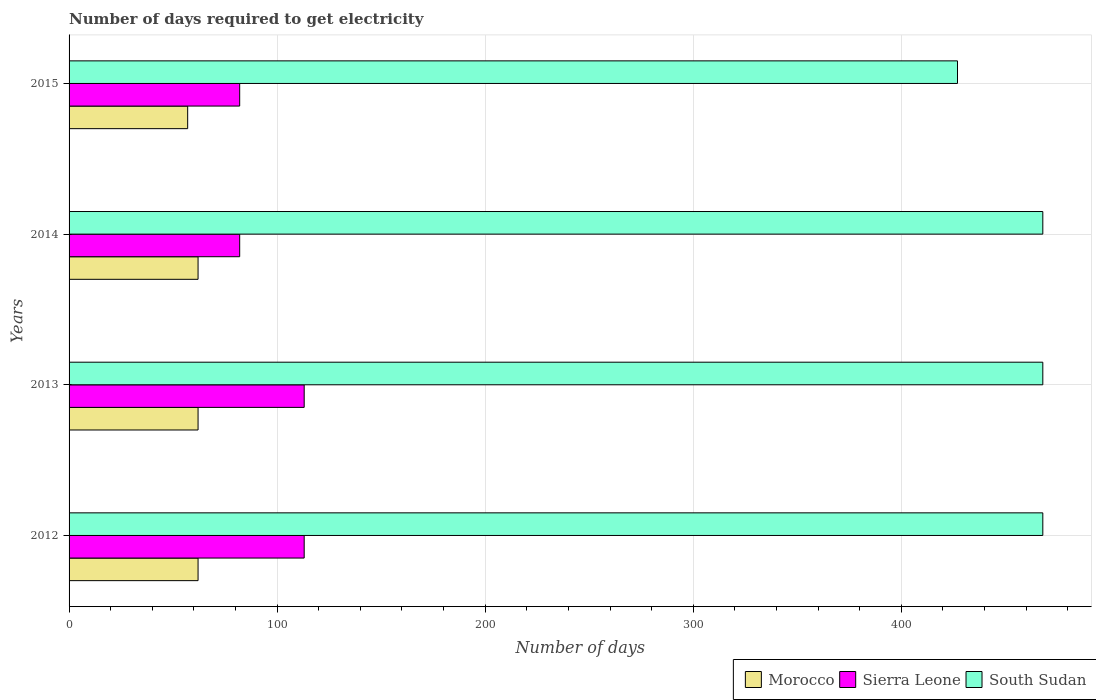How many different coloured bars are there?
Your answer should be compact. 3. Are the number of bars per tick equal to the number of legend labels?
Make the answer very short. Yes. How many bars are there on the 2nd tick from the top?
Give a very brief answer. 3. How many bars are there on the 4th tick from the bottom?
Provide a succinct answer. 3. What is the label of the 2nd group of bars from the top?
Keep it short and to the point. 2014. What is the number of days required to get electricity in in Sierra Leone in 2012?
Provide a short and direct response. 113. Across all years, what is the maximum number of days required to get electricity in in Morocco?
Your answer should be very brief. 62. Across all years, what is the minimum number of days required to get electricity in in South Sudan?
Offer a terse response. 427. What is the total number of days required to get electricity in in South Sudan in the graph?
Give a very brief answer. 1831. What is the difference between the number of days required to get electricity in in Sierra Leone in 2012 and that in 2015?
Give a very brief answer. 31. What is the difference between the number of days required to get electricity in in Morocco in 2013 and the number of days required to get electricity in in Sierra Leone in 2012?
Ensure brevity in your answer.  -51. What is the average number of days required to get electricity in in Morocco per year?
Give a very brief answer. 60.75. In the year 2012, what is the difference between the number of days required to get electricity in in South Sudan and number of days required to get electricity in in Sierra Leone?
Offer a terse response. 355. Is the difference between the number of days required to get electricity in in South Sudan in 2013 and 2014 greater than the difference between the number of days required to get electricity in in Sierra Leone in 2013 and 2014?
Offer a terse response. No. What is the difference between the highest and the second highest number of days required to get electricity in in South Sudan?
Your answer should be compact. 0. What is the difference between the highest and the lowest number of days required to get electricity in in South Sudan?
Ensure brevity in your answer.  41. Is the sum of the number of days required to get electricity in in South Sudan in 2012 and 2013 greater than the maximum number of days required to get electricity in in Morocco across all years?
Provide a short and direct response. Yes. What does the 1st bar from the top in 2014 represents?
Give a very brief answer. South Sudan. What does the 2nd bar from the bottom in 2013 represents?
Your response must be concise. Sierra Leone. Is it the case that in every year, the sum of the number of days required to get electricity in in Morocco and number of days required to get electricity in in South Sudan is greater than the number of days required to get electricity in in Sierra Leone?
Offer a very short reply. Yes. How many years are there in the graph?
Provide a short and direct response. 4. What is the difference between two consecutive major ticks on the X-axis?
Offer a very short reply. 100. Are the values on the major ticks of X-axis written in scientific E-notation?
Offer a terse response. No. Where does the legend appear in the graph?
Your response must be concise. Bottom right. How many legend labels are there?
Offer a terse response. 3. What is the title of the graph?
Provide a short and direct response. Number of days required to get electricity. Does "St. Martin (French part)" appear as one of the legend labels in the graph?
Your answer should be very brief. No. What is the label or title of the X-axis?
Make the answer very short. Number of days. What is the label or title of the Y-axis?
Keep it short and to the point. Years. What is the Number of days in Morocco in 2012?
Your answer should be compact. 62. What is the Number of days in Sierra Leone in 2012?
Provide a short and direct response. 113. What is the Number of days of South Sudan in 2012?
Offer a terse response. 468. What is the Number of days in Morocco in 2013?
Your answer should be very brief. 62. What is the Number of days of Sierra Leone in 2013?
Your response must be concise. 113. What is the Number of days in South Sudan in 2013?
Provide a succinct answer. 468. What is the Number of days of Morocco in 2014?
Ensure brevity in your answer.  62. What is the Number of days of Sierra Leone in 2014?
Offer a terse response. 82. What is the Number of days of South Sudan in 2014?
Ensure brevity in your answer.  468. What is the Number of days in Morocco in 2015?
Your answer should be very brief. 57. What is the Number of days of South Sudan in 2015?
Your answer should be very brief. 427. Across all years, what is the maximum Number of days in Morocco?
Your answer should be very brief. 62. Across all years, what is the maximum Number of days of Sierra Leone?
Your answer should be very brief. 113. Across all years, what is the maximum Number of days in South Sudan?
Your answer should be very brief. 468. Across all years, what is the minimum Number of days of Sierra Leone?
Ensure brevity in your answer.  82. Across all years, what is the minimum Number of days of South Sudan?
Provide a short and direct response. 427. What is the total Number of days in Morocco in the graph?
Give a very brief answer. 243. What is the total Number of days in Sierra Leone in the graph?
Your response must be concise. 390. What is the total Number of days of South Sudan in the graph?
Keep it short and to the point. 1831. What is the difference between the Number of days in Sierra Leone in 2012 and that in 2014?
Provide a succinct answer. 31. What is the difference between the Number of days in South Sudan in 2012 and that in 2014?
Make the answer very short. 0. What is the difference between the Number of days of Morocco in 2012 and that in 2015?
Keep it short and to the point. 5. What is the difference between the Number of days of South Sudan in 2013 and that in 2014?
Keep it short and to the point. 0. What is the difference between the Number of days of Morocco in 2013 and that in 2015?
Keep it short and to the point. 5. What is the difference between the Number of days of South Sudan in 2013 and that in 2015?
Make the answer very short. 41. What is the difference between the Number of days of Morocco in 2014 and that in 2015?
Your answer should be compact. 5. What is the difference between the Number of days in Sierra Leone in 2014 and that in 2015?
Ensure brevity in your answer.  0. What is the difference between the Number of days of Morocco in 2012 and the Number of days of Sierra Leone in 2013?
Your answer should be compact. -51. What is the difference between the Number of days in Morocco in 2012 and the Number of days in South Sudan in 2013?
Make the answer very short. -406. What is the difference between the Number of days in Sierra Leone in 2012 and the Number of days in South Sudan in 2013?
Ensure brevity in your answer.  -355. What is the difference between the Number of days in Morocco in 2012 and the Number of days in South Sudan in 2014?
Provide a succinct answer. -406. What is the difference between the Number of days in Sierra Leone in 2012 and the Number of days in South Sudan in 2014?
Ensure brevity in your answer.  -355. What is the difference between the Number of days in Morocco in 2012 and the Number of days in Sierra Leone in 2015?
Ensure brevity in your answer.  -20. What is the difference between the Number of days in Morocco in 2012 and the Number of days in South Sudan in 2015?
Offer a very short reply. -365. What is the difference between the Number of days in Sierra Leone in 2012 and the Number of days in South Sudan in 2015?
Your answer should be compact. -314. What is the difference between the Number of days of Morocco in 2013 and the Number of days of South Sudan in 2014?
Your answer should be compact. -406. What is the difference between the Number of days in Sierra Leone in 2013 and the Number of days in South Sudan in 2014?
Give a very brief answer. -355. What is the difference between the Number of days in Morocco in 2013 and the Number of days in Sierra Leone in 2015?
Provide a succinct answer. -20. What is the difference between the Number of days in Morocco in 2013 and the Number of days in South Sudan in 2015?
Give a very brief answer. -365. What is the difference between the Number of days of Sierra Leone in 2013 and the Number of days of South Sudan in 2015?
Make the answer very short. -314. What is the difference between the Number of days in Morocco in 2014 and the Number of days in Sierra Leone in 2015?
Give a very brief answer. -20. What is the difference between the Number of days of Morocco in 2014 and the Number of days of South Sudan in 2015?
Offer a terse response. -365. What is the difference between the Number of days of Sierra Leone in 2014 and the Number of days of South Sudan in 2015?
Provide a short and direct response. -345. What is the average Number of days in Morocco per year?
Keep it short and to the point. 60.75. What is the average Number of days of Sierra Leone per year?
Ensure brevity in your answer.  97.5. What is the average Number of days of South Sudan per year?
Give a very brief answer. 457.75. In the year 2012, what is the difference between the Number of days of Morocco and Number of days of Sierra Leone?
Make the answer very short. -51. In the year 2012, what is the difference between the Number of days of Morocco and Number of days of South Sudan?
Provide a short and direct response. -406. In the year 2012, what is the difference between the Number of days of Sierra Leone and Number of days of South Sudan?
Offer a very short reply. -355. In the year 2013, what is the difference between the Number of days of Morocco and Number of days of Sierra Leone?
Provide a succinct answer. -51. In the year 2013, what is the difference between the Number of days in Morocco and Number of days in South Sudan?
Your answer should be very brief. -406. In the year 2013, what is the difference between the Number of days in Sierra Leone and Number of days in South Sudan?
Give a very brief answer. -355. In the year 2014, what is the difference between the Number of days of Morocco and Number of days of South Sudan?
Give a very brief answer. -406. In the year 2014, what is the difference between the Number of days in Sierra Leone and Number of days in South Sudan?
Your response must be concise. -386. In the year 2015, what is the difference between the Number of days of Morocco and Number of days of South Sudan?
Make the answer very short. -370. In the year 2015, what is the difference between the Number of days in Sierra Leone and Number of days in South Sudan?
Make the answer very short. -345. What is the ratio of the Number of days of South Sudan in 2012 to that in 2013?
Offer a terse response. 1. What is the ratio of the Number of days of Sierra Leone in 2012 to that in 2014?
Provide a short and direct response. 1.38. What is the ratio of the Number of days in South Sudan in 2012 to that in 2014?
Keep it short and to the point. 1. What is the ratio of the Number of days of Morocco in 2012 to that in 2015?
Your answer should be compact. 1.09. What is the ratio of the Number of days of Sierra Leone in 2012 to that in 2015?
Your answer should be very brief. 1.38. What is the ratio of the Number of days of South Sudan in 2012 to that in 2015?
Offer a very short reply. 1.1. What is the ratio of the Number of days of Sierra Leone in 2013 to that in 2014?
Your answer should be compact. 1.38. What is the ratio of the Number of days in Morocco in 2013 to that in 2015?
Offer a terse response. 1.09. What is the ratio of the Number of days in Sierra Leone in 2013 to that in 2015?
Make the answer very short. 1.38. What is the ratio of the Number of days in South Sudan in 2013 to that in 2015?
Provide a short and direct response. 1.1. What is the ratio of the Number of days in Morocco in 2014 to that in 2015?
Your answer should be very brief. 1.09. What is the ratio of the Number of days in Sierra Leone in 2014 to that in 2015?
Ensure brevity in your answer.  1. What is the ratio of the Number of days in South Sudan in 2014 to that in 2015?
Provide a succinct answer. 1.1. What is the difference between the highest and the second highest Number of days in Sierra Leone?
Your response must be concise. 0. What is the difference between the highest and the second highest Number of days in South Sudan?
Give a very brief answer. 0. What is the difference between the highest and the lowest Number of days of Sierra Leone?
Your answer should be very brief. 31. What is the difference between the highest and the lowest Number of days in South Sudan?
Make the answer very short. 41. 